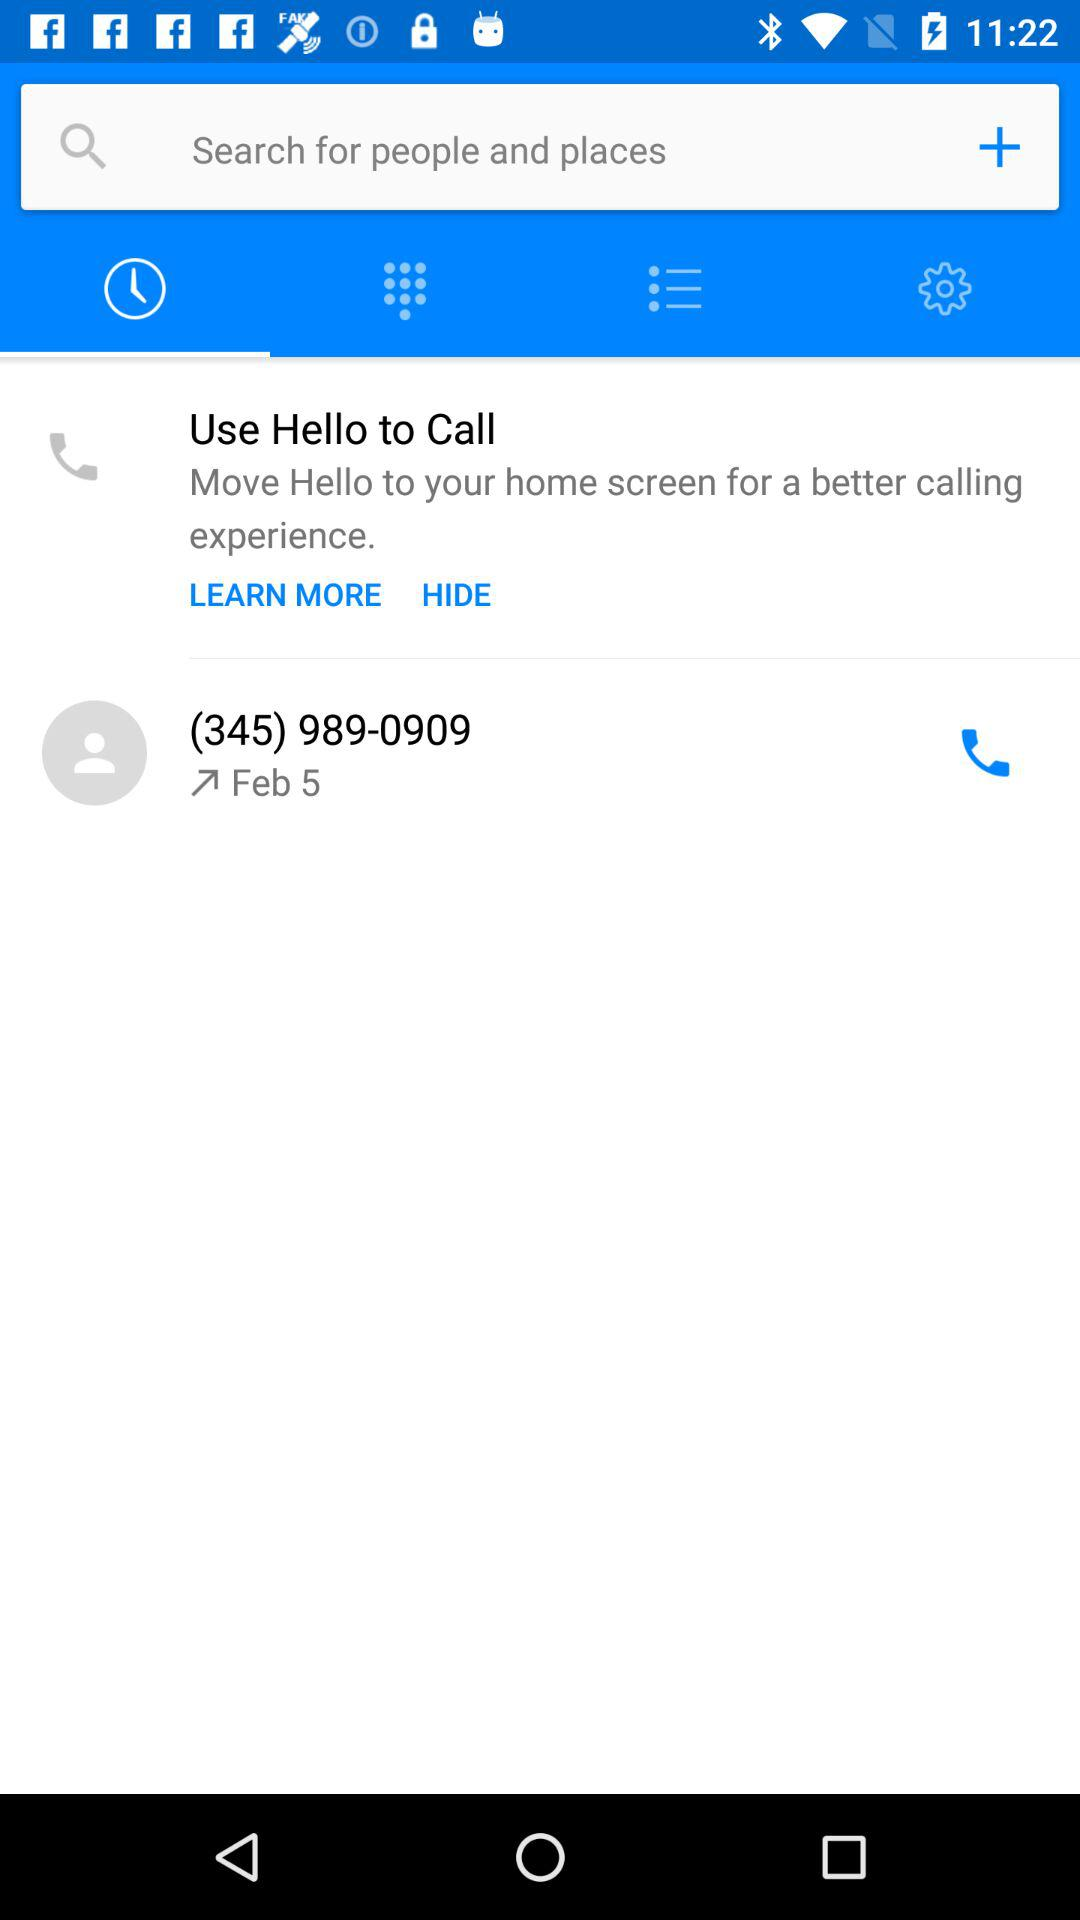What is the date of the outgoing call? The date of the outgoing call is February 5. 